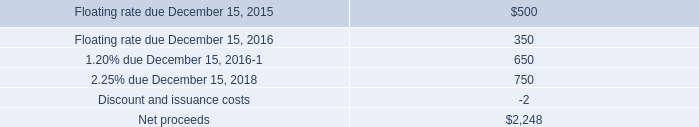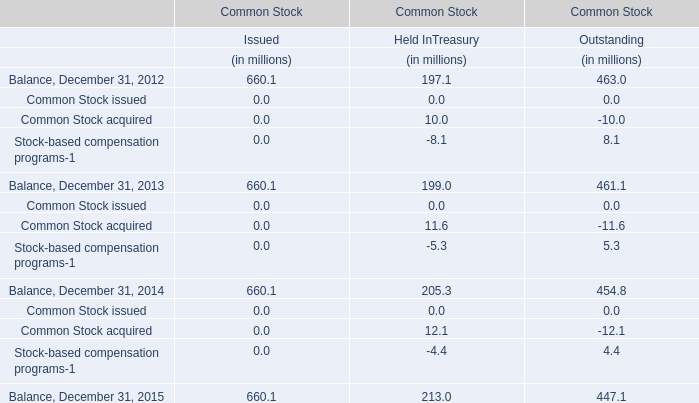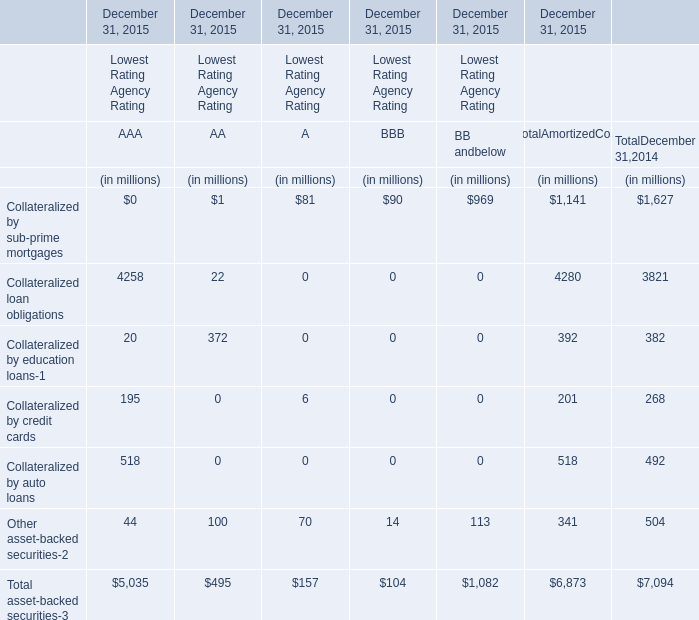If Collateralized loan obligations for total amortized cost develops with the same growth rate in 2015, what will it reach in 2016? (in million) 
Computations: ((((4280 - 3821) / 3821) + 1) * 4280)
Answer: 4794.13766. 